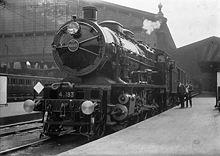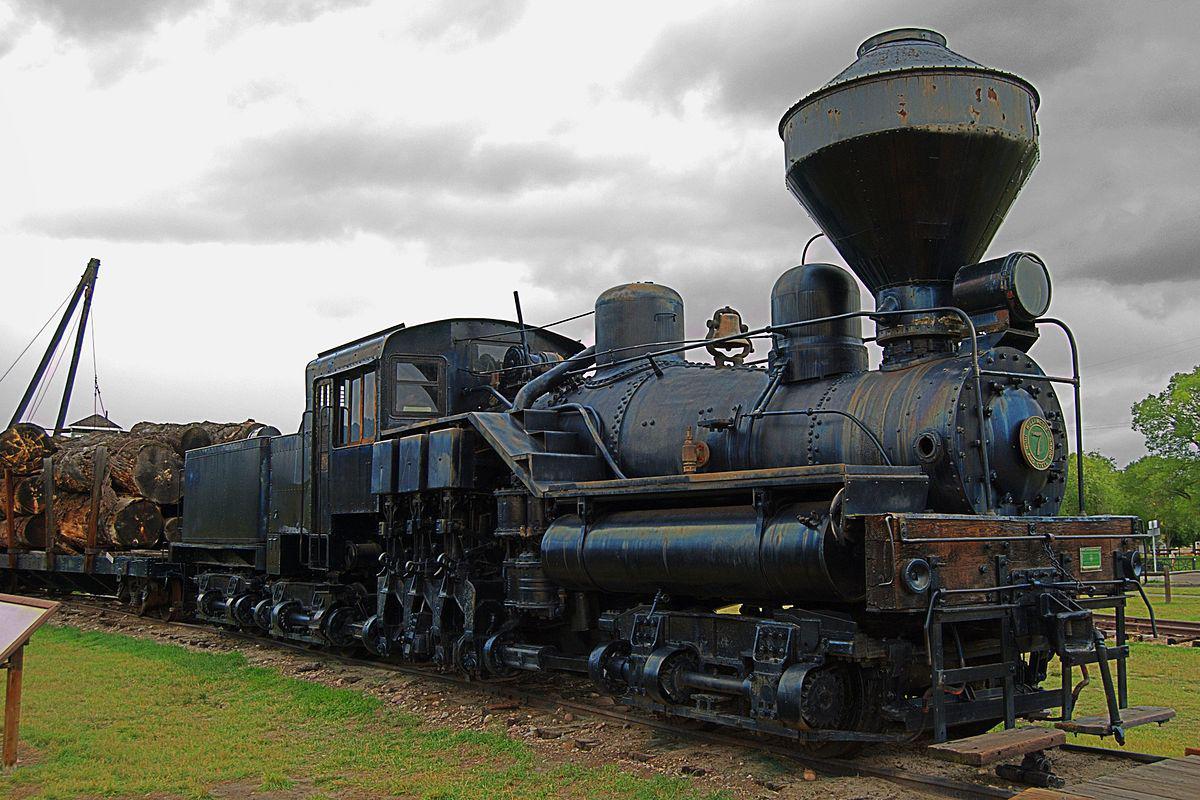The first image is the image on the left, the second image is the image on the right. Analyze the images presented: Is the assertion "The train in the left image is heading towards the left." valid? Answer yes or no. Yes. The first image is the image on the left, the second image is the image on the right. Assess this claim about the two images: "There are two trains moving towards the right.". Correct or not? Answer yes or no. No. 